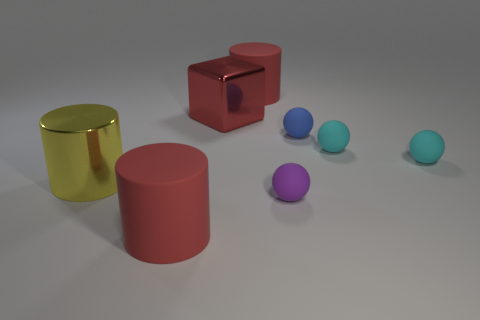I'm curious about the lighting in the image. Where do you think the light source is located? Based on the shadows and highlights, the light source appears to be coming from the top right side of the frame, casting shadows towards the bottom left. This direction is consistent across all the objects in the image. 